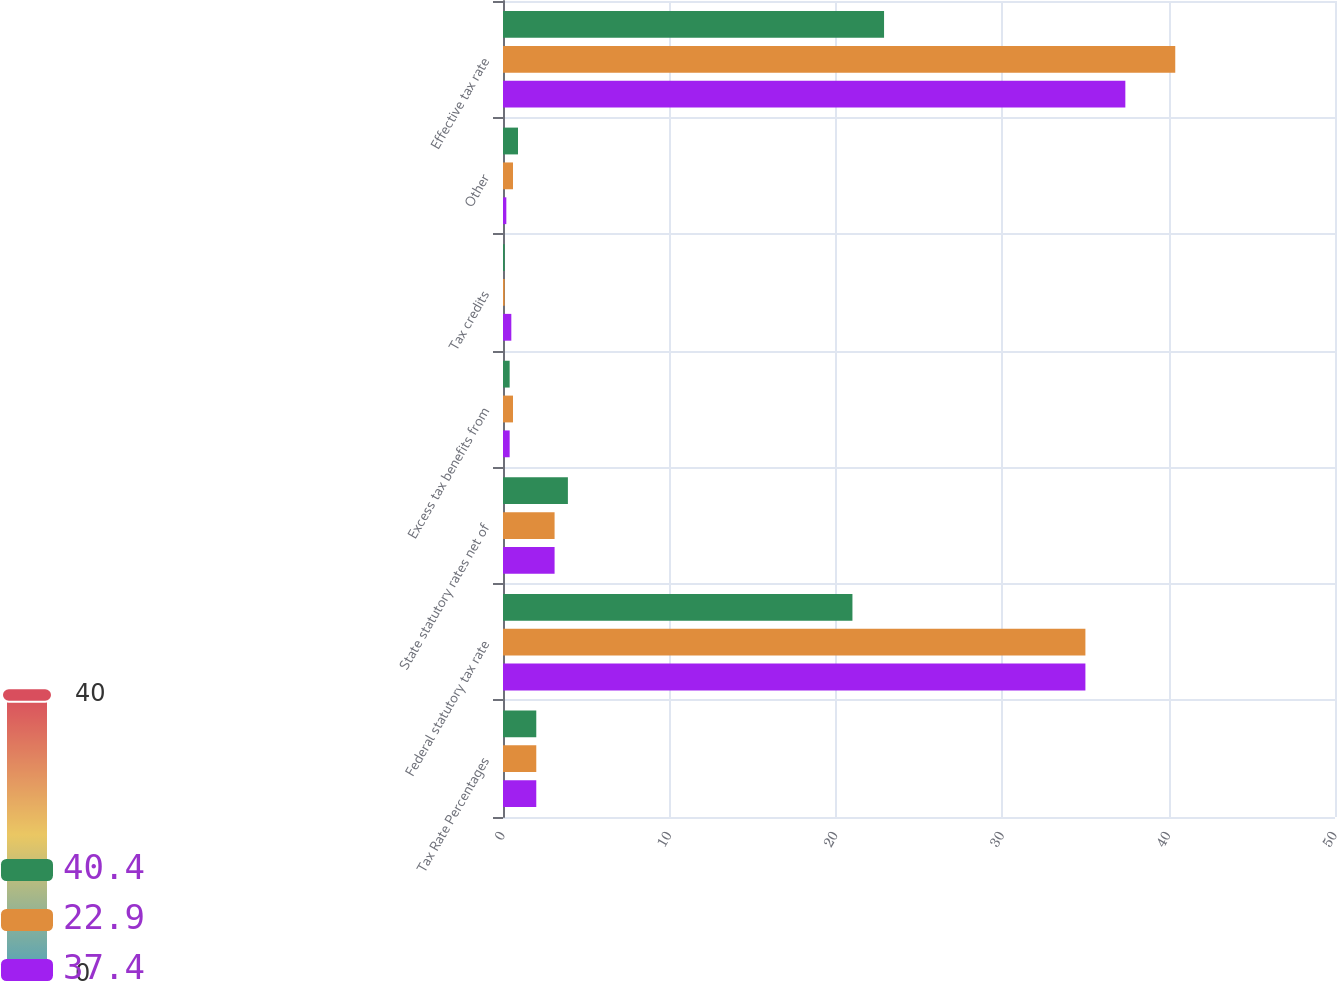<chart> <loc_0><loc_0><loc_500><loc_500><stacked_bar_chart><ecel><fcel>Tax Rate Percentages<fcel>Federal statutory tax rate<fcel>State statutory rates net of<fcel>Excess tax benefits from<fcel>Tax credits<fcel>Other<fcel>Effective tax rate<nl><fcel>40.4<fcel>2<fcel>21<fcel>3.9<fcel>0.4<fcel>0.1<fcel>0.9<fcel>22.9<nl><fcel>22.9<fcel>2<fcel>35<fcel>3.1<fcel>0.6<fcel>0.1<fcel>0.6<fcel>40.4<nl><fcel>37.4<fcel>2<fcel>35<fcel>3.1<fcel>0.4<fcel>0.5<fcel>0.2<fcel>37.4<nl></chart> 